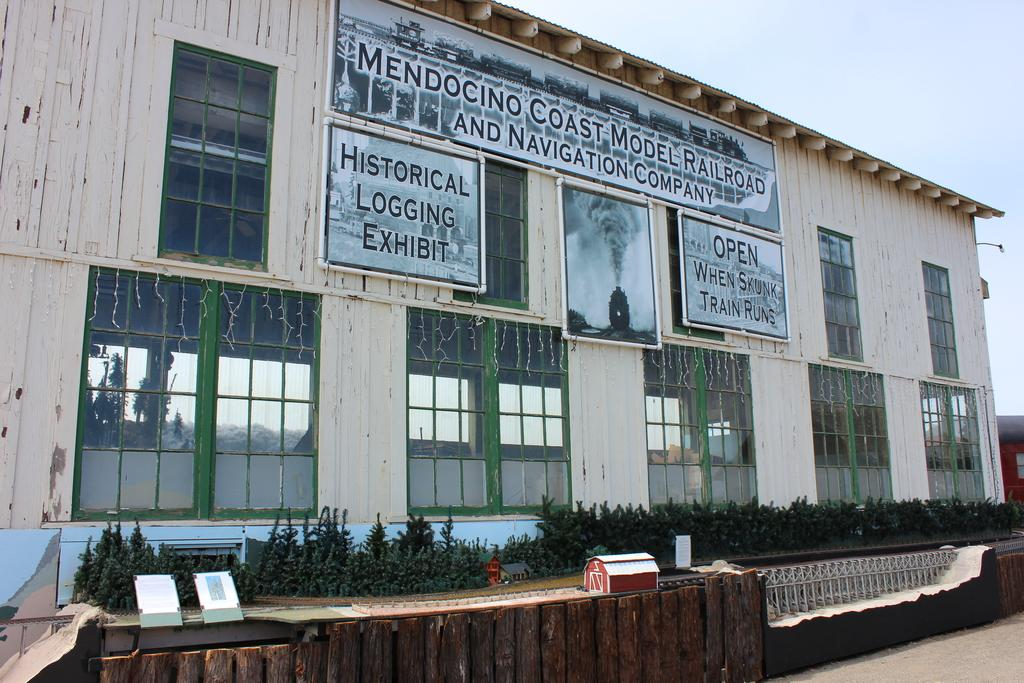What can be seen in the sky in the image? The sky is visible in the image. What type of structures are present in the image? There are buildings and a shed in the image. Are there any decorative elements on the buildings? Yes, decor lights are present on the windows. What else can be seen in the image besides buildings and the sky? Plants and grills are visible in the image. What is the source of light in the image? A street light is in the image. What type of behavior can be observed in the slaves in the image? There are no slaves or any indication of slavery in the image. 